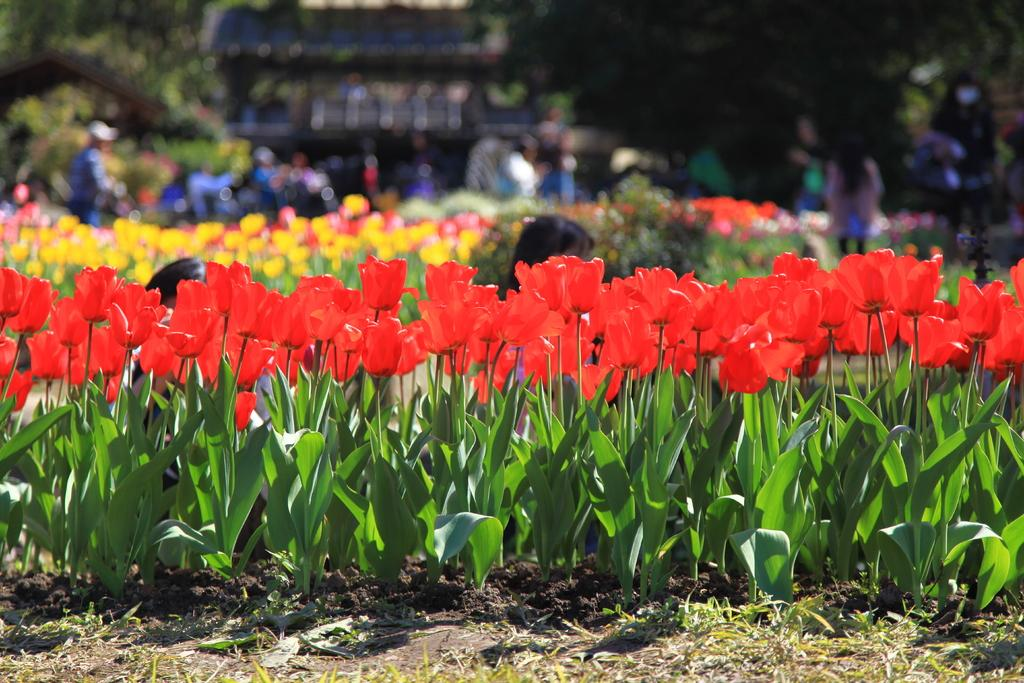What type of plants can be seen in the image? There are plants with red flowers on the ground. What can be seen in the background of the image? There are persons, plants with flowers, and a building in the background. What color is the gold sock worn by the person in the image? There is no mention of gold or socks in the image; it features plants with red flowers and a background with persons, plants with flowers, and a building. 